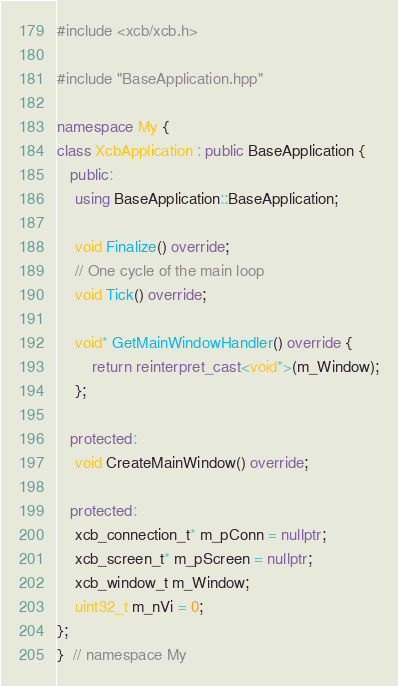Convert code to text. <code><loc_0><loc_0><loc_500><loc_500><_C++_>#include <xcb/xcb.h>

#include "BaseApplication.hpp"

namespace My {
class XcbApplication : public BaseApplication {
   public:
    using BaseApplication::BaseApplication;

    void Finalize() override;
    // One cycle of the main loop
    void Tick() override;

    void* GetMainWindowHandler() override {
        return reinterpret_cast<void*>(m_Window);
    };

   protected:
    void CreateMainWindow() override;

   protected:
    xcb_connection_t* m_pConn = nullptr;
    xcb_screen_t* m_pScreen = nullptr;
    xcb_window_t m_Window;
    uint32_t m_nVi = 0;
};
}  // namespace My
</code> 